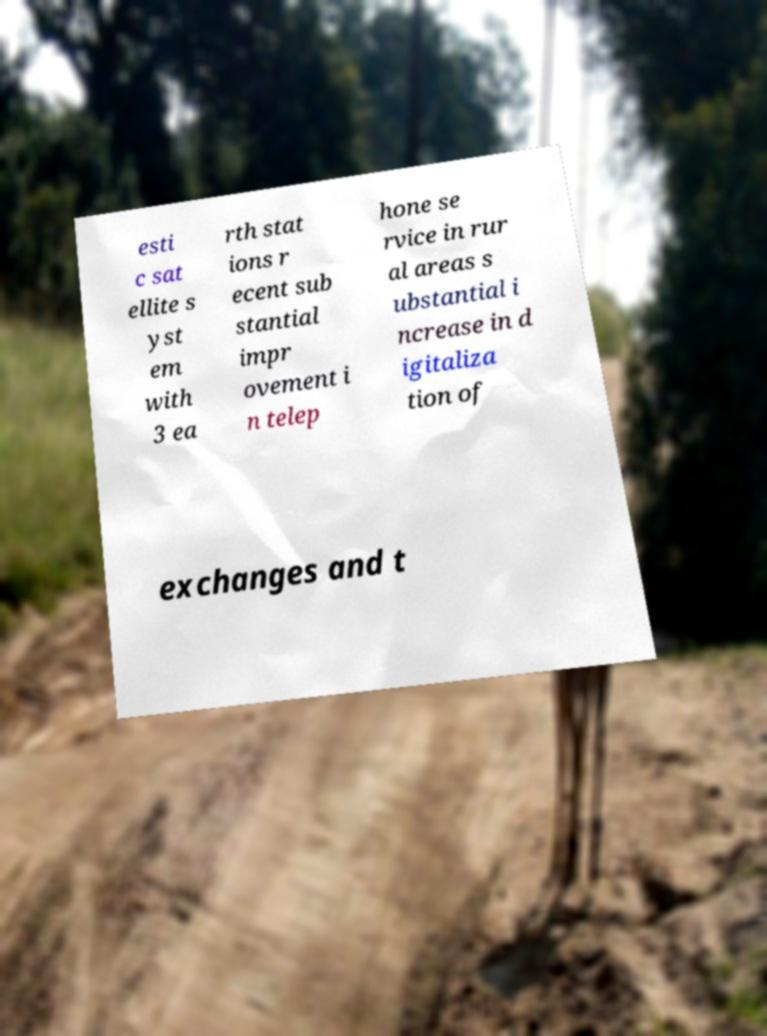What messages or text are displayed in this image? I need them in a readable, typed format. esti c sat ellite s yst em with 3 ea rth stat ions r ecent sub stantial impr ovement i n telep hone se rvice in rur al areas s ubstantial i ncrease in d igitaliza tion of exchanges and t 